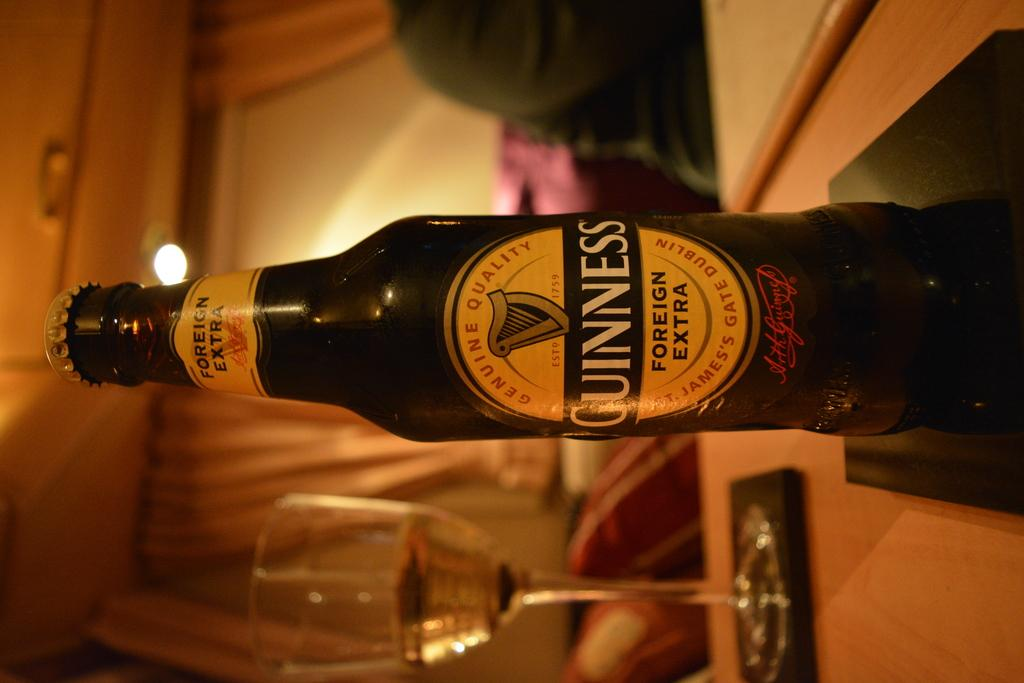<image>
Present a compact description of the photo's key features. the word Guiness that is on the bottle 